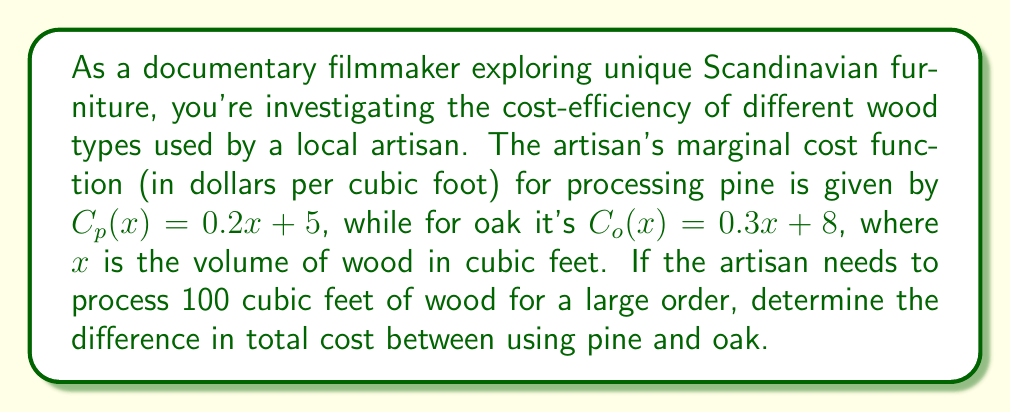Can you solve this math problem? To solve this problem, we need to follow these steps:

1. Find the total cost function for each wood type by integrating the marginal cost function.
2. Calculate the total cost for processing 100 cubic feet of each wood type.
3. Determine the difference between the two total costs.

Step 1: Finding the total cost functions

For pine:
$$\int C_p(x) dx = \int (0.2x + 5) dx = 0.1x^2 + 5x + K$$
Let $T_p(x)$ be the total cost function for pine: $T_p(x) = 0.1x^2 + 5x$

For oak:
$$\int C_o(x) dx = \int (0.3x + 8) dx = 0.15x^2 + 8x + K$$
Let $T_o(x)$ be the total cost function for oak: $T_o(x) = 0.15x^2 + 8x$

Step 2: Calculating total costs for 100 cubic feet

For pine:
$T_p(100) = 0.1(100)^2 + 5(100) = 1000 + 500 = 1500$

For oak:
$T_o(100) = 0.15(100)^2 + 8(100) = 1500 + 800 = 2300$

Step 3: Determining the difference in total cost

Difference = Total cost of oak - Total cost of pine
$2300 - 1500 = 800$

Therefore, the difference in total cost between using oak and pine for processing 100 cubic feet of wood is $800.
Answer: $800 